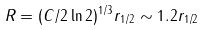<formula> <loc_0><loc_0><loc_500><loc_500>R = ( C / 2 \ln { 2 } ) ^ { 1 / 3 } r _ { 1 / 2 } \sim 1 . 2 r _ { 1 / 2 }</formula> 